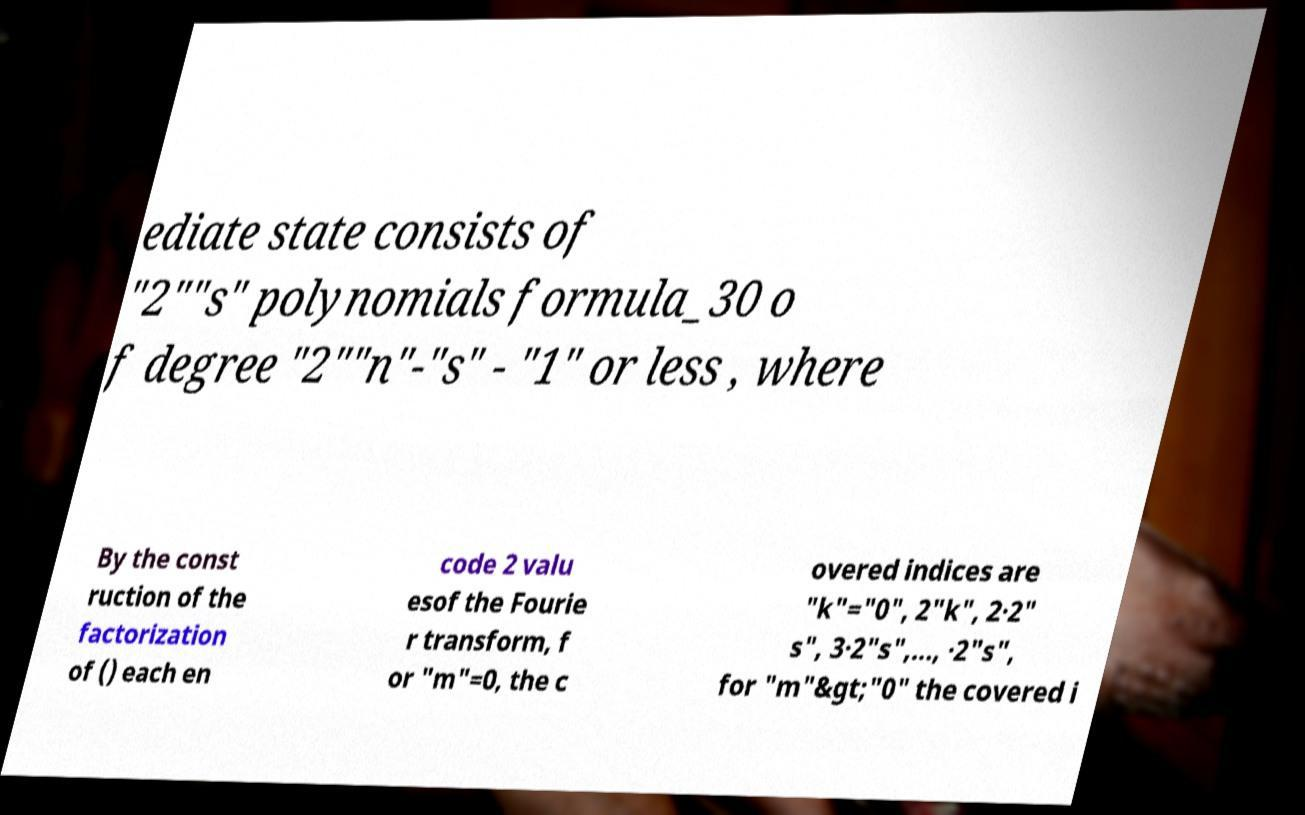There's text embedded in this image that I need extracted. Can you transcribe it verbatim? ediate state consists of "2""s" polynomials formula_30 o f degree "2""n"-"s" - "1" or less , where By the const ruction of the factorization of () each en code 2 valu esof the Fourie r transform, f or "m"=0, the c overed indices are "k"="0", 2"k", 2∙2" s", 3∙2"s",…, ∙2"s", for "m"&gt;"0" the covered i 